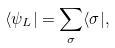<formula> <loc_0><loc_0><loc_500><loc_500>\langle \psi _ { L } | = \sum _ { \sigma } \langle \sigma | ,</formula> 